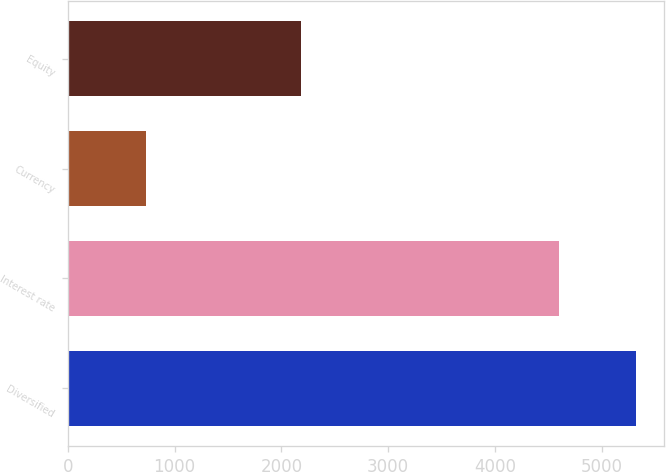<chart> <loc_0><loc_0><loc_500><loc_500><bar_chart><fcel>Diversified<fcel>Interest rate<fcel>Currency<fcel>Equity<nl><fcel>5316<fcel>4600<fcel>729<fcel>2183<nl></chart> 